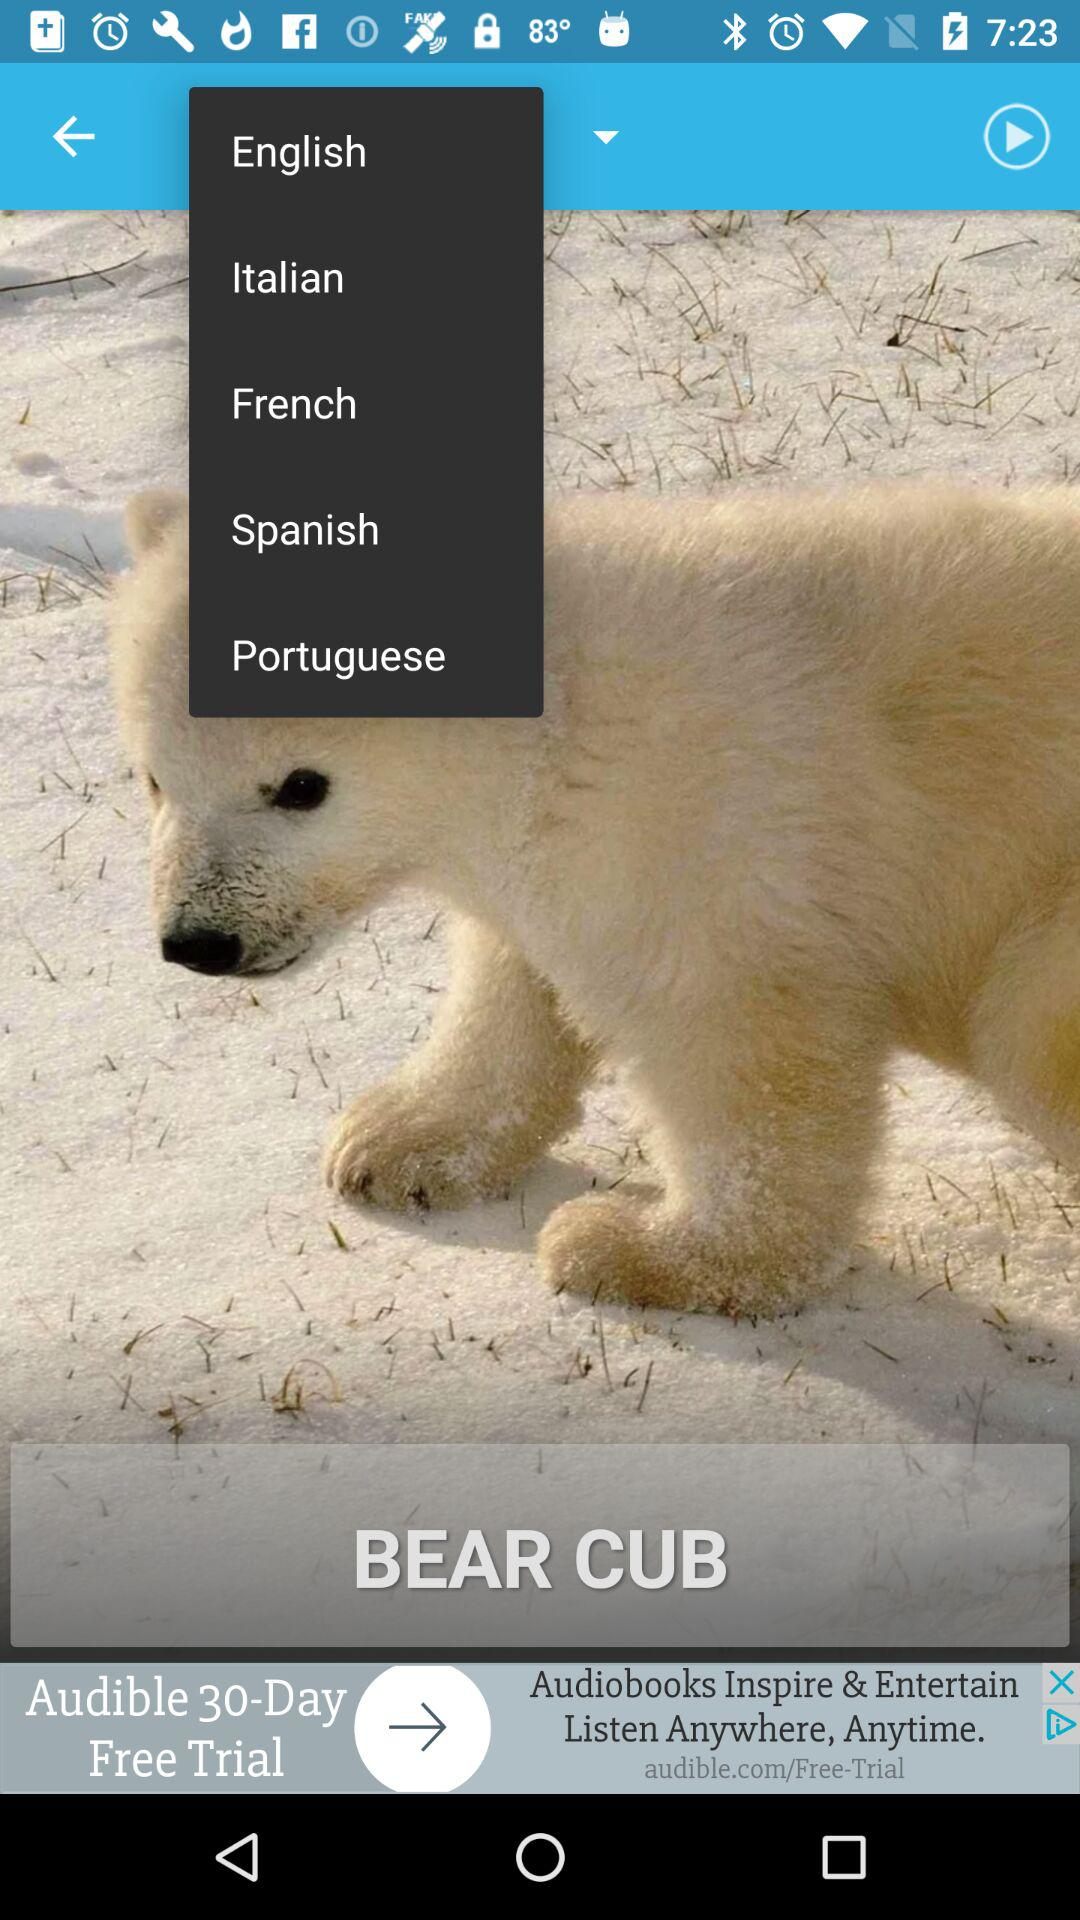What are the languages available in the list? The available languages are English, Italian, French, Spanish and Portuguese. 